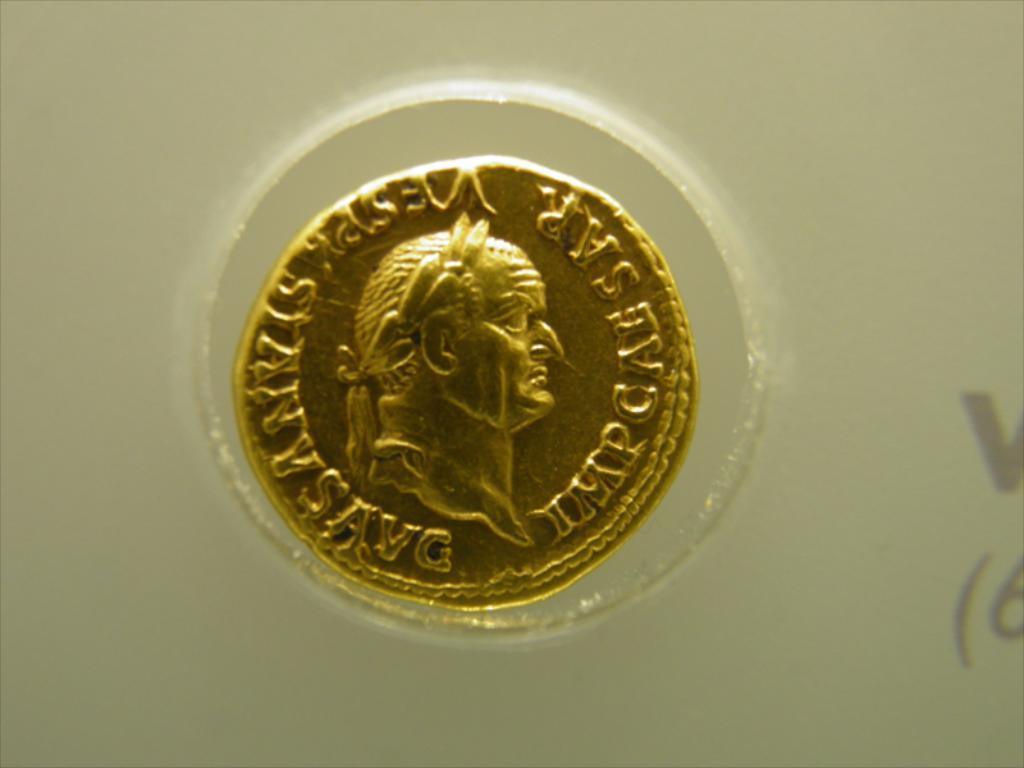<image>
Summarize the visual content of the image. Gold coin with a face on it which says "Impcaesar". 